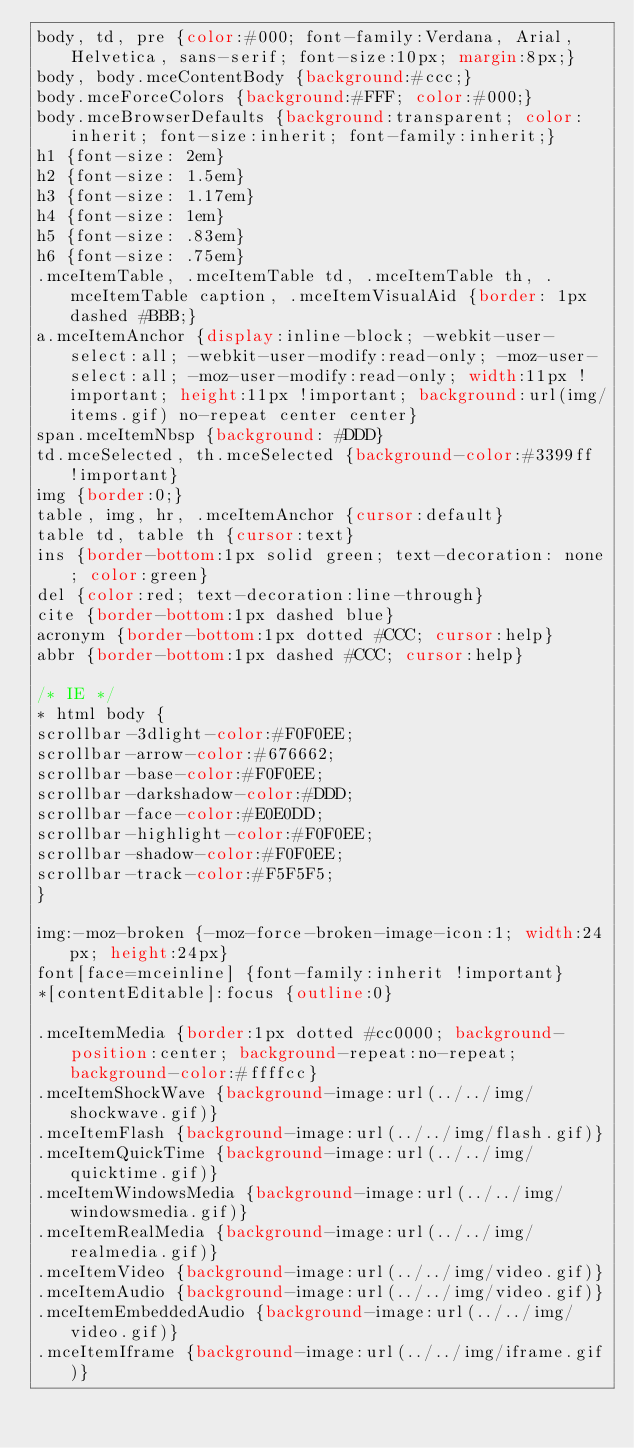<code> <loc_0><loc_0><loc_500><loc_500><_CSS_>body, td, pre {color:#000; font-family:Verdana, Arial, Helvetica, sans-serif; font-size:10px; margin:8px;}
body, body.mceContentBody {background:#ccc;}
body.mceForceColors {background:#FFF; color:#000;}
body.mceBrowserDefaults {background:transparent; color:inherit; font-size:inherit; font-family:inherit;}
h1 {font-size: 2em}
h2 {font-size: 1.5em}
h3 {font-size: 1.17em}
h4 {font-size: 1em}
h5 {font-size: .83em}
h6 {font-size: .75em}
.mceItemTable, .mceItemTable td, .mceItemTable th, .mceItemTable caption, .mceItemVisualAid {border: 1px dashed #BBB;}
a.mceItemAnchor {display:inline-block; -webkit-user-select:all; -webkit-user-modify:read-only; -moz-user-select:all; -moz-user-modify:read-only; width:11px !important; height:11px !important; background:url(img/items.gif) no-repeat center center}
span.mceItemNbsp {background: #DDD}
td.mceSelected, th.mceSelected {background-color:#3399ff !important}
img {border:0;}
table, img, hr, .mceItemAnchor {cursor:default}
table td, table th {cursor:text}
ins {border-bottom:1px solid green; text-decoration: none; color:green}
del {color:red; text-decoration:line-through}
cite {border-bottom:1px dashed blue}
acronym {border-bottom:1px dotted #CCC; cursor:help}
abbr {border-bottom:1px dashed #CCC; cursor:help}

/* IE */
* html body {
scrollbar-3dlight-color:#F0F0EE;
scrollbar-arrow-color:#676662;
scrollbar-base-color:#F0F0EE;
scrollbar-darkshadow-color:#DDD;
scrollbar-face-color:#E0E0DD;
scrollbar-highlight-color:#F0F0EE;
scrollbar-shadow-color:#F0F0EE;
scrollbar-track-color:#F5F5F5;
}

img:-moz-broken {-moz-force-broken-image-icon:1; width:24px; height:24px}
font[face=mceinline] {font-family:inherit !important}
*[contentEditable]:focus {outline:0}

.mceItemMedia {border:1px dotted #cc0000; background-position:center; background-repeat:no-repeat; background-color:#ffffcc}
.mceItemShockWave {background-image:url(../../img/shockwave.gif)}
.mceItemFlash {background-image:url(../../img/flash.gif)}
.mceItemQuickTime {background-image:url(../../img/quicktime.gif)}
.mceItemWindowsMedia {background-image:url(../../img/windowsmedia.gif)}
.mceItemRealMedia {background-image:url(../../img/realmedia.gif)}
.mceItemVideo {background-image:url(../../img/video.gif)}
.mceItemAudio {background-image:url(../../img/video.gif)}
.mceItemEmbeddedAudio {background-image:url(../../img/video.gif)}
.mceItemIframe {background-image:url(../../img/iframe.gif)}</code> 